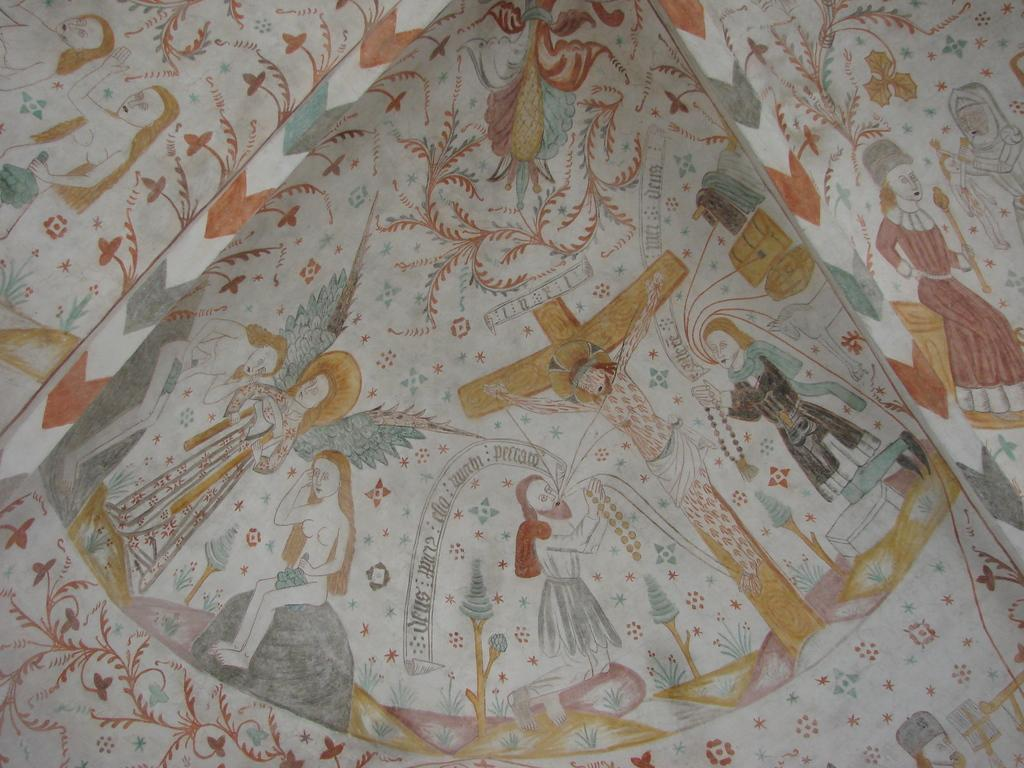What is the main subject of the image? The main subject of the image is a depiction of persons. Can you describe any additional elements in the image? Yes, there are some designs in the image. What type of teaching method is being used in the image? There is no teaching method present in the image, as it only depicts persons and designs. 